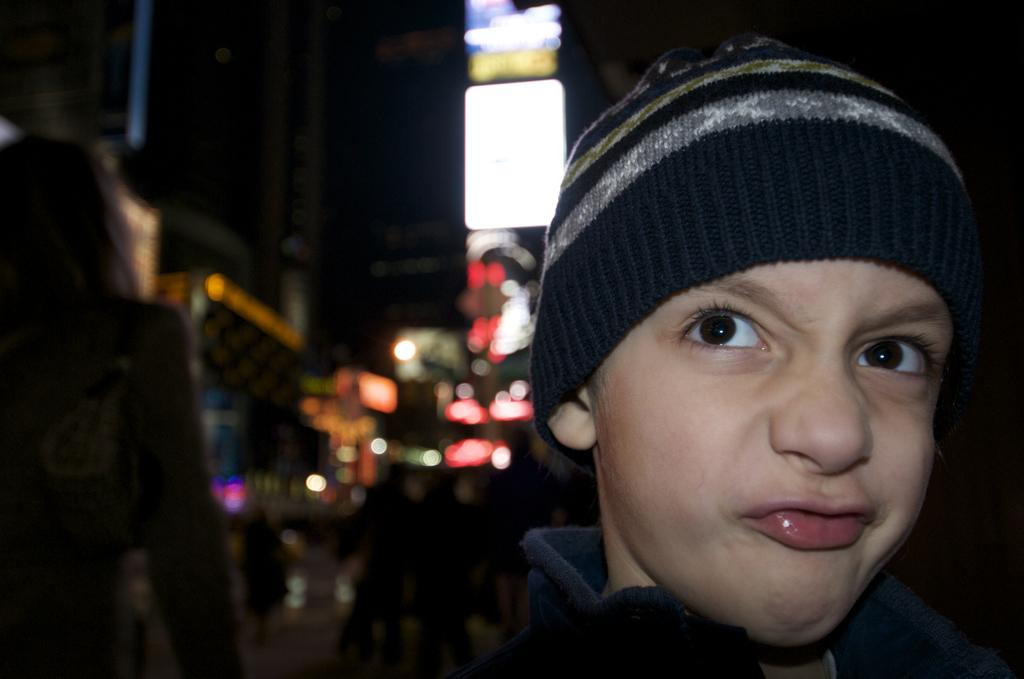What is the main subject of the image? The main subject of the image is a kid. What is the kid wearing on their head? The kid is wearing a skullcap. Can you describe the people behind the kid? There are other persons behind the kid, but their specific features are not clear due to the blurred background. What type of structures can be seen in the image? There are buildings visible in the image. What can be seen illuminating the scene? There are lights present in the image. How many houses can be seen exchanging gifts in the image? There are no houses present in the image, and no exchange of gifts is depicted. 